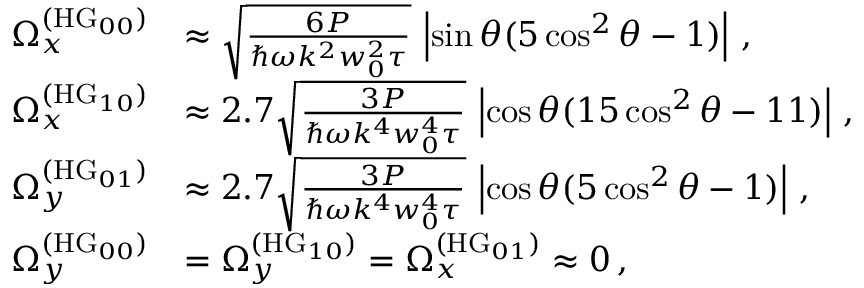Convert formula to latex. <formula><loc_0><loc_0><loc_500><loc_500>\begin{array} { r l } { \Omega _ { x } ^ { ( H G _ { 0 0 } ) } } & { \approx \sqrt { \frac { 6 P } { \hbar { \omega } k ^ { 2 } w _ { 0 } ^ { 2 } \tau } } \, \left | \sin \theta ( 5 \cos ^ { 2 } \theta - 1 ) \right | \, , } \\ { \Omega _ { x } ^ { ( H G _ { 1 0 } ) } } & { \approx 2 . 7 \sqrt { \frac { 3 P } { \hbar { \omega } k ^ { 4 } w _ { 0 } ^ { 4 } \tau } } \, \left | \cos \theta ( 1 5 \cos ^ { 2 } \theta - 1 1 ) \right | \, , } \\ { \Omega _ { y } ^ { ( H G _ { 0 1 } ) } } & { \approx 2 . 7 \sqrt { \frac { 3 P } { \hbar { \omega } k ^ { 4 } w _ { 0 } ^ { 4 } \tau } } \, \left | \cos \theta ( 5 \cos ^ { 2 } \theta - 1 ) \right | \, , } \\ { \Omega _ { y } ^ { ( H G _ { 0 0 } ) } } & { = \Omega _ { y } ^ { ( H G _ { 1 0 } ) } = \Omega _ { x } ^ { ( H G _ { 0 1 } ) } \approx 0 \, , } \end{array}</formula> 